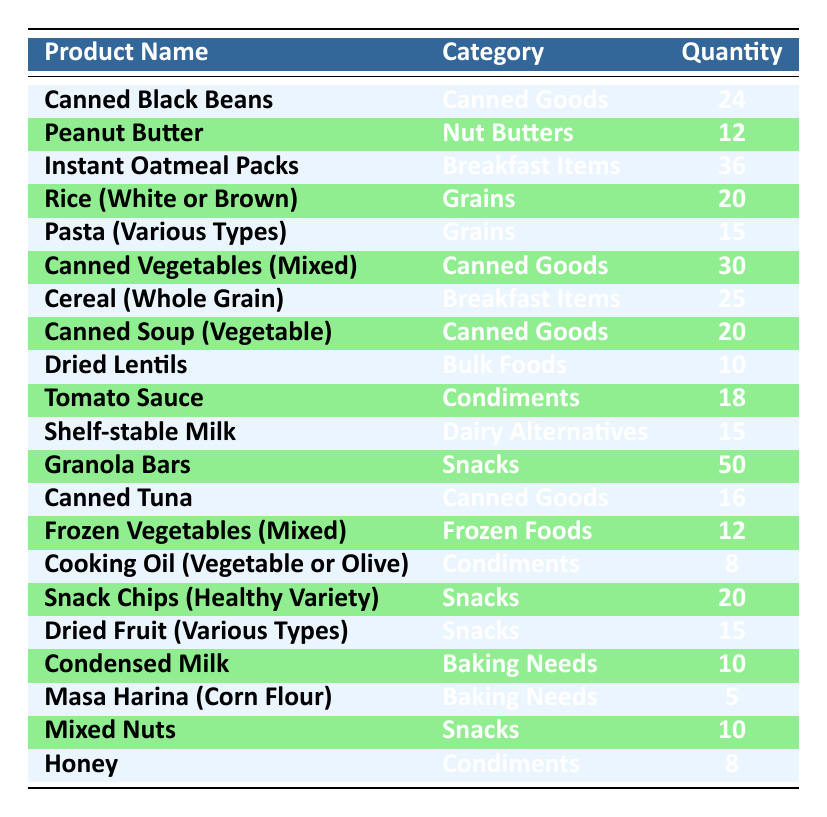What is the total quantity of canned goods donated? The quantities for canned goods are: Canned Black Beans (24), Canned Vegetables (30), Canned Soup (20), and Canned Tuna (16). Adding these gives: 24 + 30 + 20 + 16 = 90.
Answer: 90 Which product has the highest donation quantity? Looking at the quantities, Granola Bars (50) has the highest amount compared to all other products listed.
Answer: Granola Bars Is the quantity of Rice (White or Brown) greater than Pasta (Various Types)? Rice (White or Brown) has a quantity of 20, while Pasta (Various Types) has a quantity of 15. Comparing these two, 20 is greater than 15.
Answer: Yes What is the total quantity of snacks donated? The snack donations are as follows: Granola Bars (50), Snack Chips (20), Dried Fruit (15), and Mixed Nuts (10). Summing these amounts: 50 + 20 + 15 + 10 = 95.
Answer: 95 How many more Breakfast Items were donated than Bulk Foods? Breakfast Items donated include Instant Oatmeal Packs (36) and Cereal (Whole Grain) (25), totaling 36 + 25 = 61. For Bulk Foods, Dried Lentils quantity is 10. Now, calculating the difference: 61 - 10 = 51.
Answer: 51 Does the table contain more items in the Condiments category than Dairy Alternatives? There are two items in Condiments: Tomato Sauce (18), Cooking Oil (8), and Honey (8) making a total of 3. For Dairy Alternatives, there is 1 item (Shelf-stable Milk). Since 3 is greater than 1, the statement is true.
Answer: Yes What is the average quantity of all the donated products? To find the average, sum all quantities: 24 + 12 + 36 + 20 + 15 + 30 + 25 + 20 + 10 + 18 + 15 + 50 + 16 + 12 + 8 + 20 + 15 + 10 + 5 + 10 + 8 =  353. There are 21 products, so the average is 353 / 21 ≈ 16.81.
Answer: Approximately 16.81 Which category has the least quantity donated? After examining the categories, Baking Needs have only 15 (Condensed Milk 10 + Masa Harina 5) while Snacks (95) have the highest. Therefore, Baking Needs has the least total quantity.
Answer: Baking Needs How many donations are there in the Grains category? The Grains category includes Rice (20) and Pasta (15). Adding these together gives us 20 + 15 = 35.
Answer: 35 